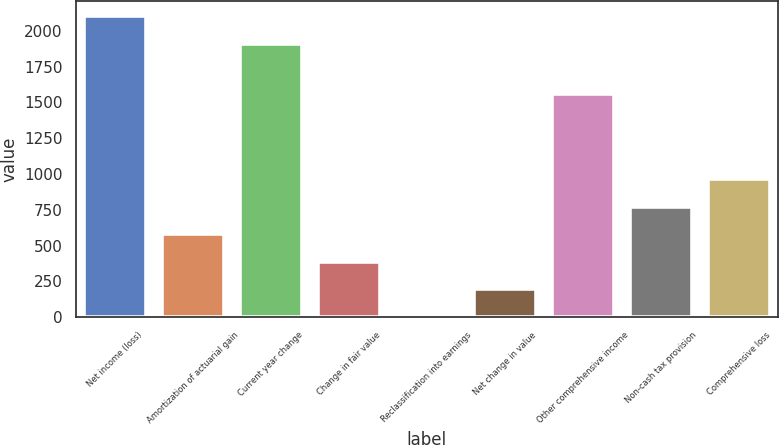Convert chart to OTSL. <chart><loc_0><loc_0><loc_500><loc_500><bar_chart><fcel>Net income (loss)<fcel>Amortization of actuarial gain<fcel>Current year change<fcel>Change in fair value<fcel>Reclassification into earnings<fcel>Net change in value<fcel>Other comprehensive income<fcel>Non-cash tax provision<fcel>Comprehensive loss<nl><fcel>2102.3<fcel>579.9<fcel>1910<fcel>387.6<fcel>3<fcel>195.3<fcel>1556<fcel>772.2<fcel>964.5<nl></chart> 